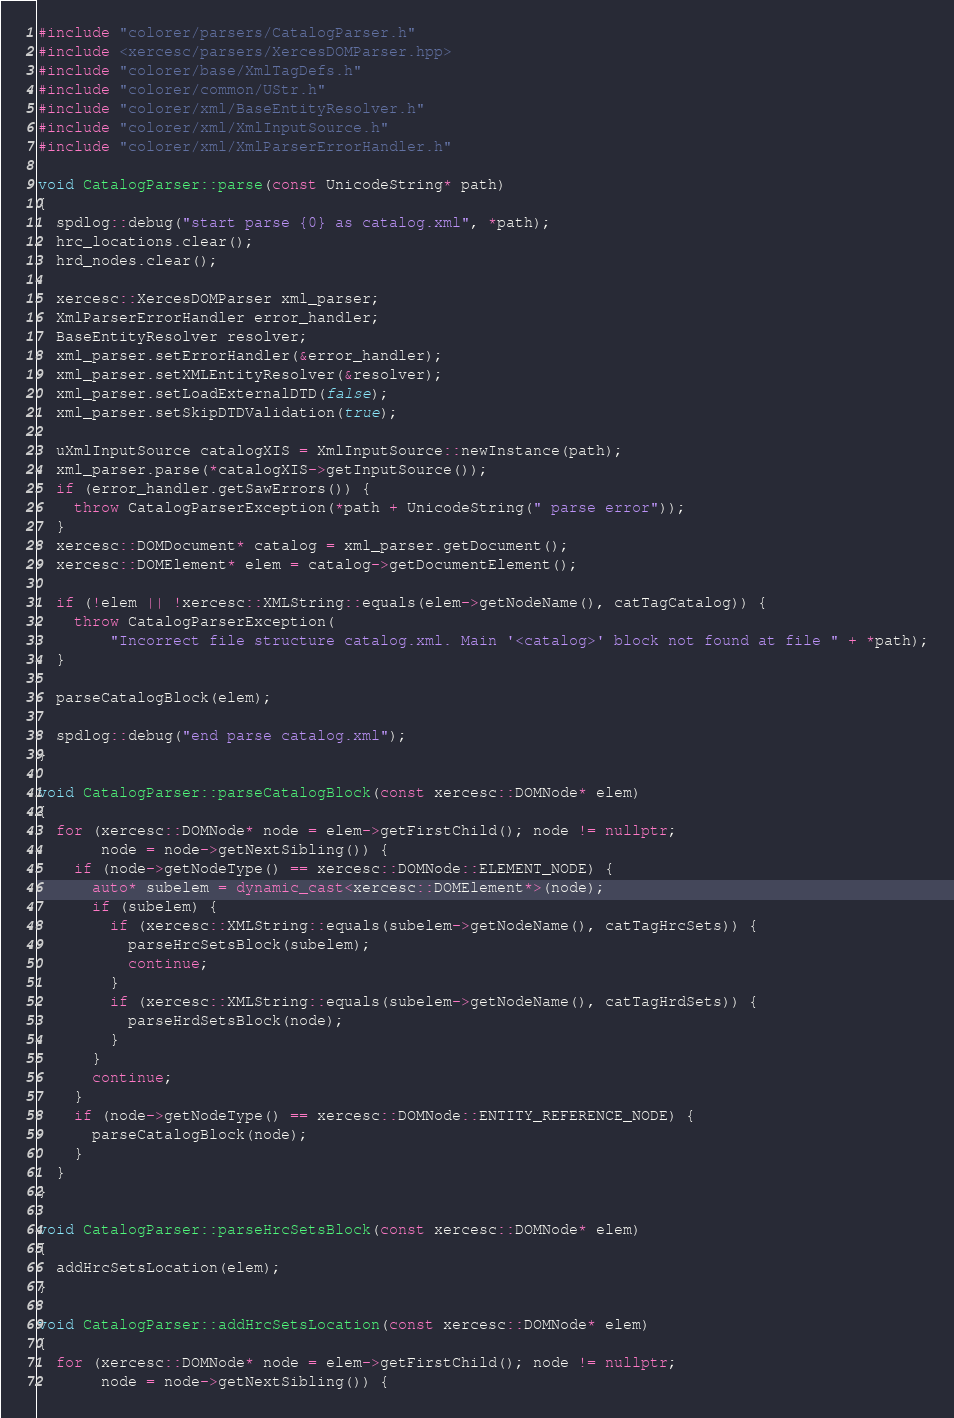Convert code to text. <code><loc_0><loc_0><loc_500><loc_500><_C++_>#include "colorer/parsers/CatalogParser.h"
#include <xercesc/parsers/XercesDOMParser.hpp>
#include "colorer/base/XmlTagDefs.h"
#include "colorer/common/UStr.h"
#include "colorer/xml/BaseEntityResolver.h"
#include "colorer/xml/XmlInputSource.h"
#include "colorer/xml/XmlParserErrorHandler.h"

void CatalogParser::parse(const UnicodeString* path)
{
  spdlog::debug("start parse {0} as catalog.xml", *path);
  hrc_locations.clear();
  hrd_nodes.clear();

  xercesc::XercesDOMParser xml_parser;
  XmlParserErrorHandler error_handler;
  BaseEntityResolver resolver;
  xml_parser.setErrorHandler(&error_handler);
  xml_parser.setXMLEntityResolver(&resolver);
  xml_parser.setLoadExternalDTD(false);
  xml_parser.setSkipDTDValidation(true);

  uXmlInputSource catalogXIS = XmlInputSource::newInstance(path);
  xml_parser.parse(*catalogXIS->getInputSource());
  if (error_handler.getSawErrors()) {
    throw CatalogParserException(*path + UnicodeString(" parse error"));
  }
  xercesc::DOMDocument* catalog = xml_parser.getDocument();
  xercesc::DOMElement* elem = catalog->getDocumentElement();

  if (!elem || !xercesc::XMLString::equals(elem->getNodeName(), catTagCatalog)) {
    throw CatalogParserException(
        "Incorrect file structure catalog.xml. Main '<catalog>' block not found at file " + *path);
  }

  parseCatalogBlock(elem);

  spdlog::debug("end parse catalog.xml");
}

void CatalogParser::parseCatalogBlock(const xercesc::DOMNode* elem)
{
  for (xercesc::DOMNode* node = elem->getFirstChild(); node != nullptr;
       node = node->getNextSibling()) {
    if (node->getNodeType() == xercesc::DOMNode::ELEMENT_NODE) {
      auto* subelem = dynamic_cast<xercesc::DOMElement*>(node);
      if (subelem) {
        if (xercesc::XMLString::equals(subelem->getNodeName(), catTagHrcSets)) {
          parseHrcSetsBlock(subelem);
          continue;
        }
        if (xercesc::XMLString::equals(subelem->getNodeName(), catTagHrdSets)) {
          parseHrdSetsBlock(node);
        }
      }
      continue;
    }
    if (node->getNodeType() == xercesc::DOMNode::ENTITY_REFERENCE_NODE) {
      parseCatalogBlock(node);
    }
  }
}

void CatalogParser::parseHrcSetsBlock(const xercesc::DOMNode* elem)
{
  addHrcSetsLocation(elem);
}

void CatalogParser::addHrcSetsLocation(const xercesc::DOMNode* elem)
{
  for (xercesc::DOMNode* node = elem->getFirstChild(); node != nullptr;
       node = node->getNextSibling()) {</code> 